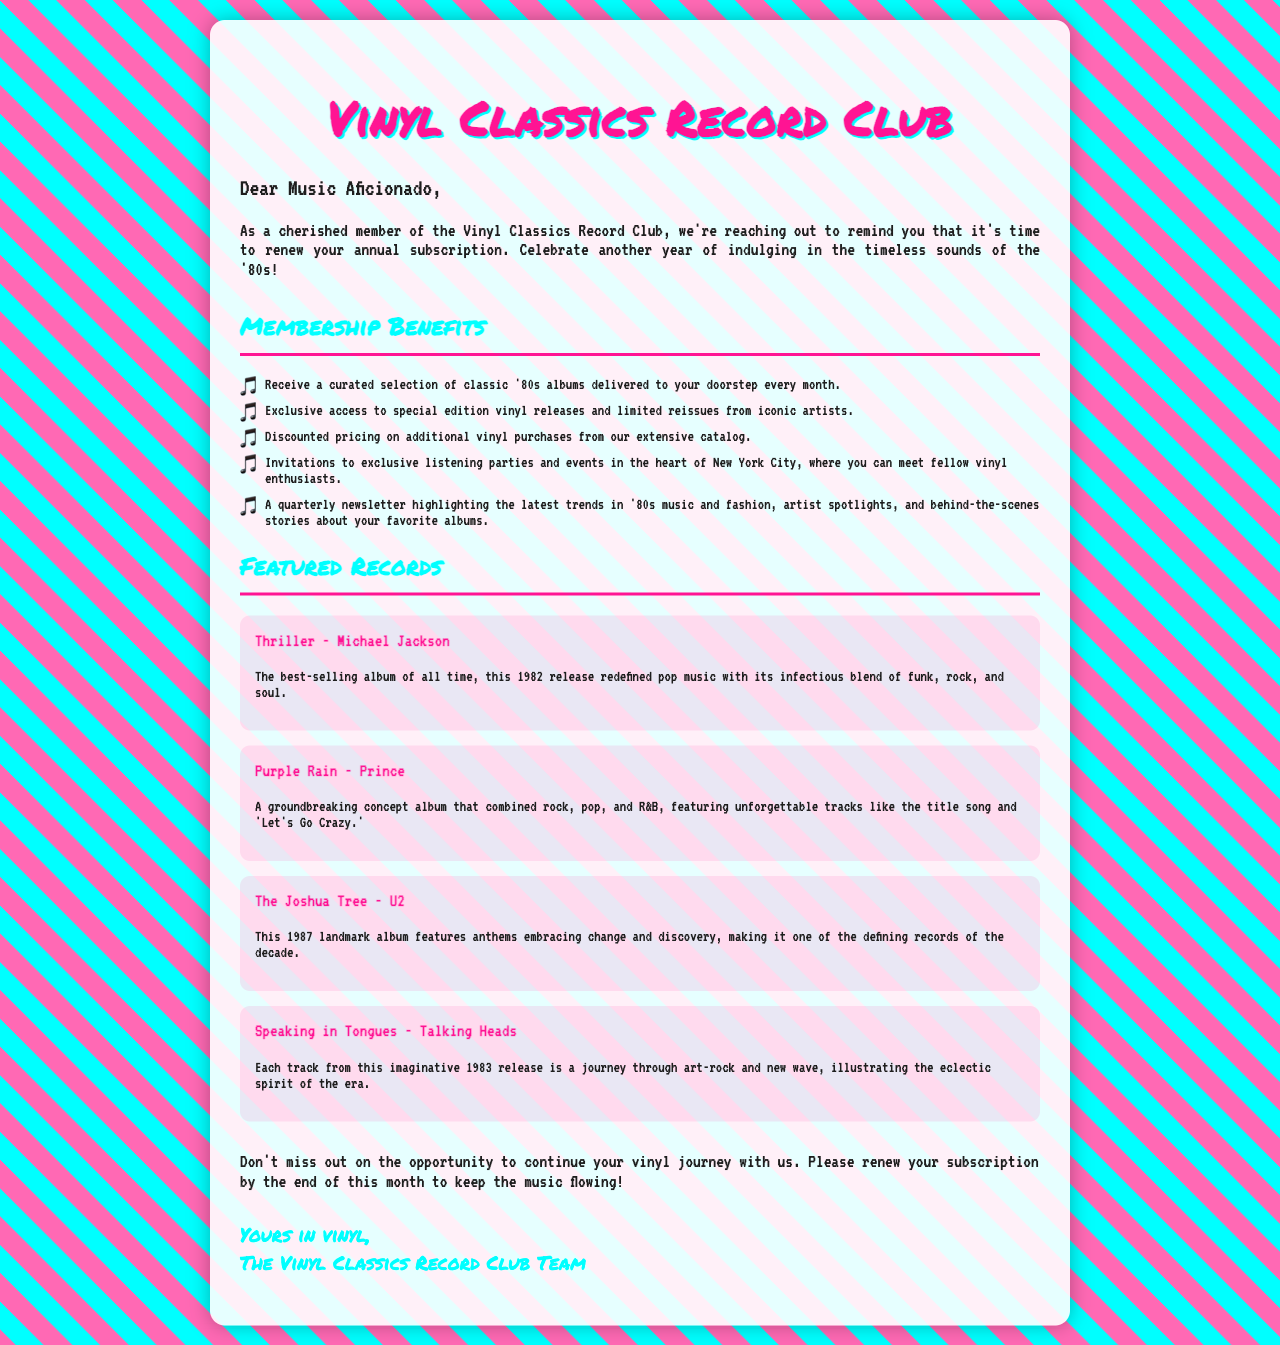What is the name of the club? The title of the document identifies the organization.
Answer: Vinyl Classics Record Club Who is the letter addressed to? The opening greeting specifies the recipient of the letter.
Answer: Music Aficionado How many membership benefits are listed? Counting the items in the membership benefits section reveals the total.
Answer: Five What is the first featured record? The first record mentioned in the featured records section is identified.
Answer: Thriller - Michael Jackson What year was "Purple Rain" released? The description of "Purple Rain" specifies its release year.
Answer: 1984 What type of events do members get invited to? The membership benefits mention specific types of events members can attend.
Answer: Listening parties What do members receive each month? The introduction of the membership benefits section specifies monthly offerings.
Answer: Curated selection of classic '80s albums When is the deadline to renew the subscription? The closing section specifies the deadline for renewal.
Answer: End of this month 